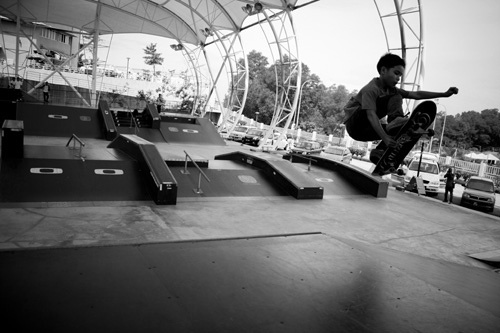Describe the objects in this image and their specific colors. I can see people in black, gray, darkgray, and lightgray tones, skateboard in black, gray, darkgray, and lightgray tones, car in black, lightgray, darkgray, and gray tones, car in black, gray, darkgray, and lightgray tones, and car in black, darkgray, lightgray, and gray tones in this image. 